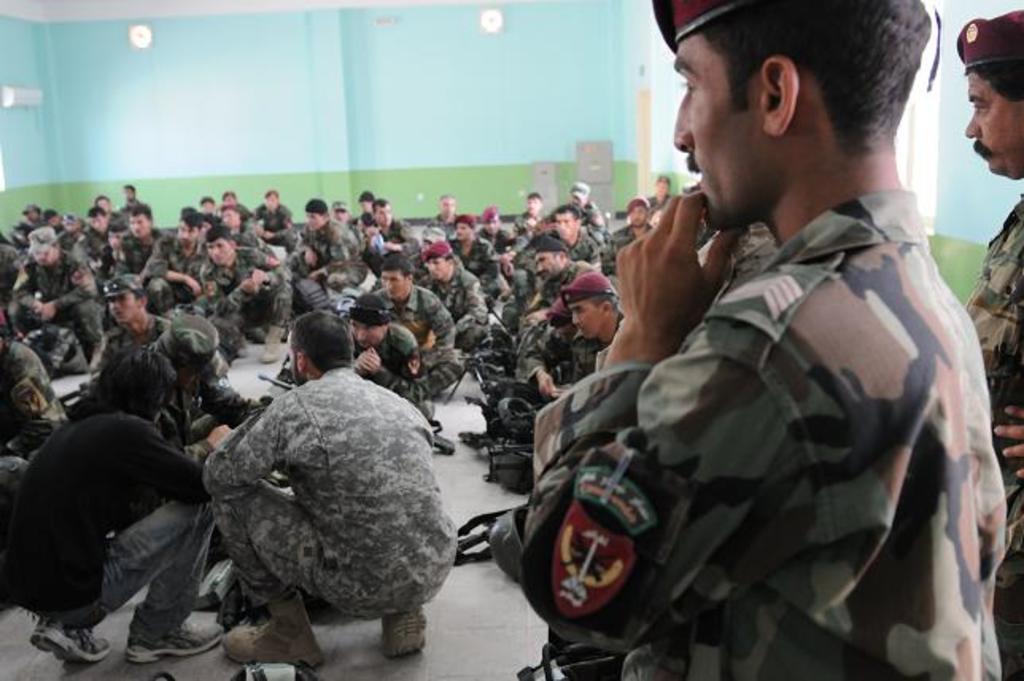In one or two sentences, can you explain what this image depicts? In this image I can see a person wearing military uniform is standing and I can see few other persons are sitting on the floor. In the background I can see the wall which is blue and green in color, the ceiling and few white colored objects to the wall. 